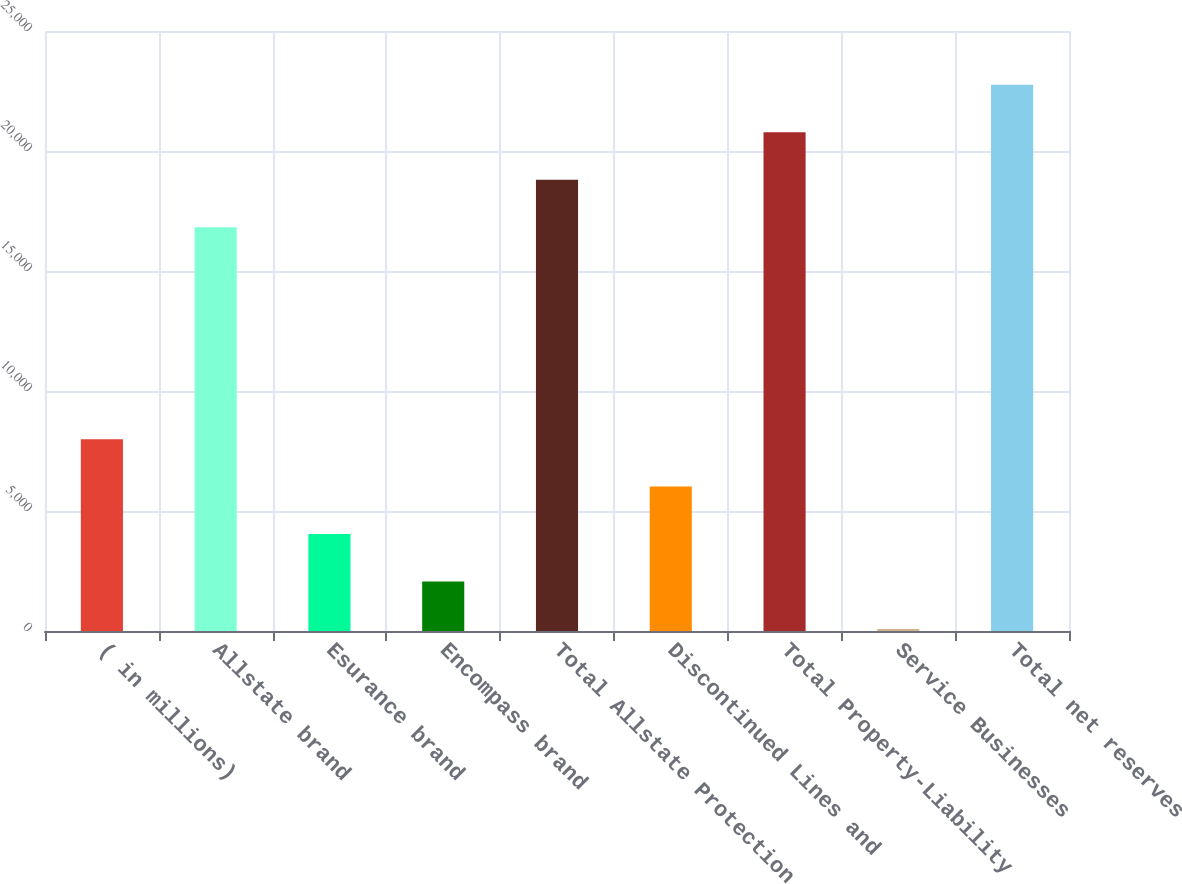Convert chart to OTSL. <chart><loc_0><loc_0><loc_500><loc_500><bar_chart><fcel>( in millions)<fcel>Allstate brand<fcel>Esurance brand<fcel>Encompass brand<fcel>Total Allstate Protection<fcel>Discontinued Lines and<fcel>Total Property-Liability<fcel>Service Businesses<fcel>Total net reserves<nl><fcel>7993.2<fcel>16826<fcel>4039.6<fcel>2062.8<fcel>18802.8<fcel>6016.4<fcel>20779.6<fcel>86<fcel>22756.4<nl></chart> 